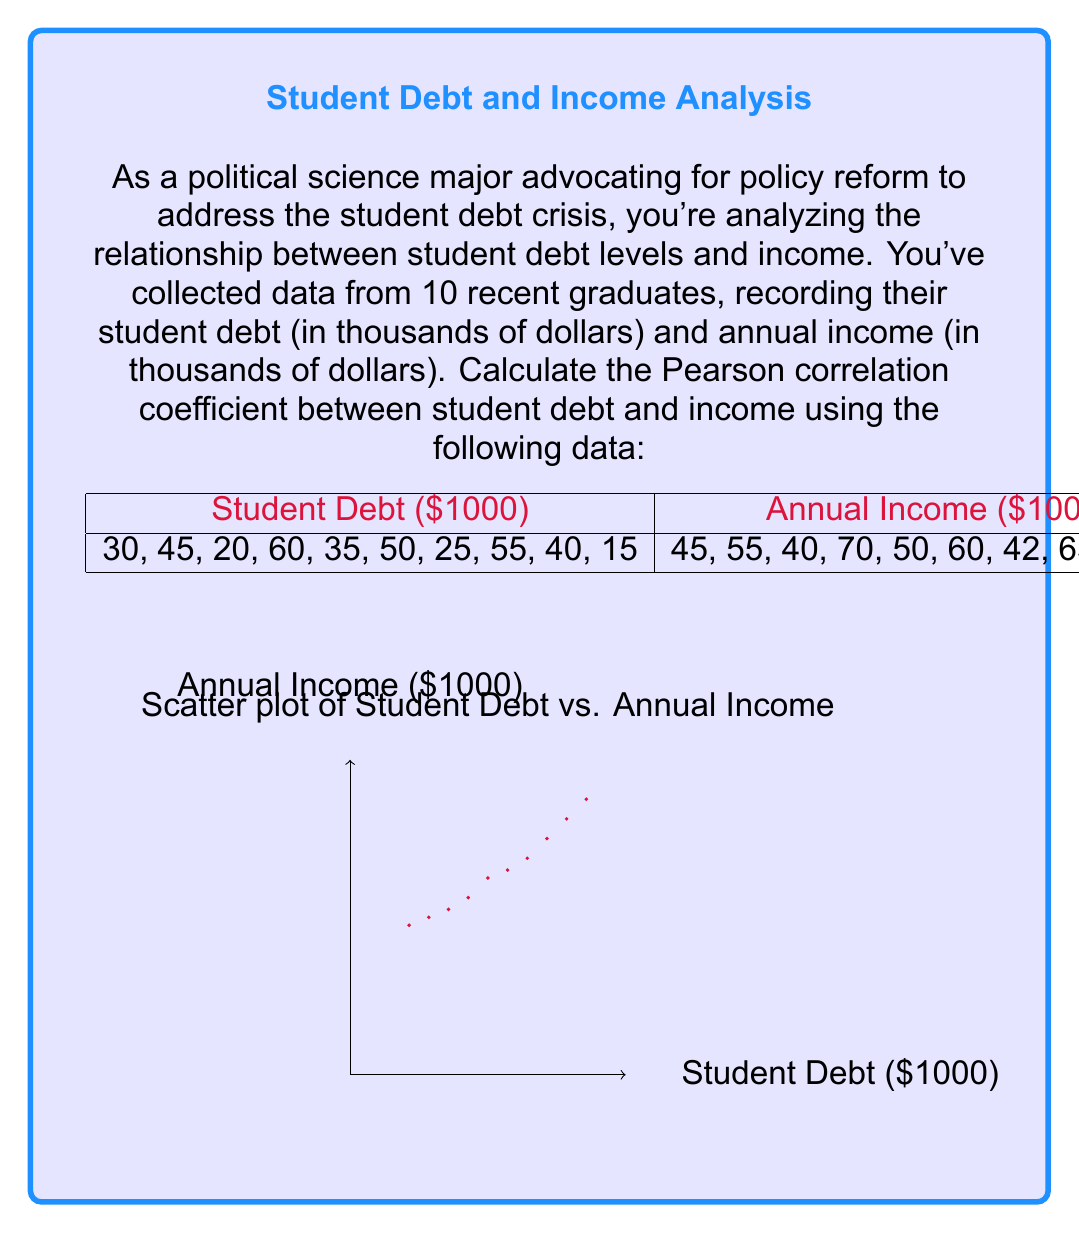Can you solve this math problem? To calculate the Pearson correlation coefficient (r) between student debt and income, we'll follow these steps:

1. Calculate the means of student debt ($\bar{X}$) and income ($\bar{Y}$):
   $$\bar{X} = \frac{30+45+20+60+35+50+25+55+40+15}{10} = 37.5$$
   $$\bar{Y} = \frac{45+55+40+70+50+60+42+65+52+38}{10} = 51.7$$

2. Calculate the deviations from the mean for each variable:
   $X - \bar{X}$ and $Y - \bar{Y}$

3. Calculate the products of these deviations:
   $(X - \bar{X})(Y - \bar{Y})$

4. Sum up these products:
   $$\sum(X - \bar{X})(Y - \bar{Y}) = 1318.5$$

5. Calculate the sum of squared deviations for each variable:
   $$\sum(X - \bar{X})^2 = 2268.75$$
   $$\sum(Y - \bar{Y})^2 = 1014.1$$

6. Apply the formula for Pearson correlation coefficient:
   $$r = \frac{\sum(X - \bar{X})(Y - \bar{Y})}{\sqrt{\sum(X - \bar{X})^2 \sum(Y - \bar{Y})^2}}$$

7. Substitute the values:
   $$r = \frac{1318.5}{\sqrt{2268.75 \times 1014.1}} = \frac{1318.5}{1516.83} \approx 0.8692$$

The Pearson correlation coefficient is approximately 0.8692, indicating a strong positive correlation between student debt and income for this sample.
Answer: $r \approx 0.8692$ 